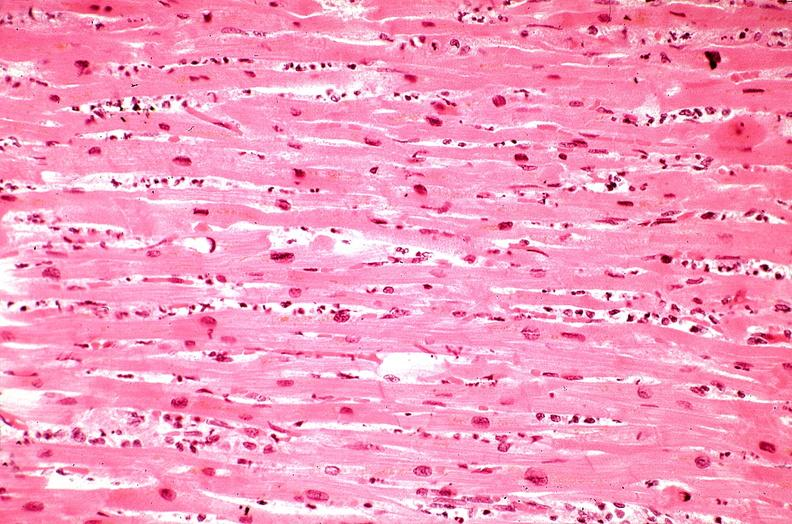s an opened peritoneal cavity cause by fibrous band strangulation present?
Answer the question using a single word or phrase. No 